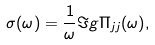<formula> <loc_0><loc_0><loc_500><loc_500>\sigma ( \omega ) = \frac { 1 } { \omega } \Im g { \Pi _ { j j } ( \omega ) } ,</formula> 